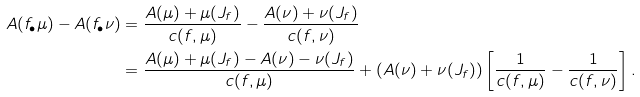Convert formula to latex. <formula><loc_0><loc_0><loc_500><loc_500>A ( f _ { \bullet } \mu ) - A ( f _ { \bullet } \nu ) & = \frac { A ( \mu ) + \mu ( J _ { f } ) } { c ( f , \mu ) } - \frac { A ( \nu ) + \nu ( J _ { f } ) } { c ( f , \nu ) } \\ & = \frac { A ( \mu ) + \mu ( J _ { f } ) - A ( \nu ) - \nu ( J _ { f } ) } { c ( f , \mu ) } + ( A ( \nu ) + \nu ( J _ { f } ) ) \left [ \frac { 1 } { c ( f , \mu ) } - \frac { 1 } { c ( f , \nu ) } \right ] .</formula> 